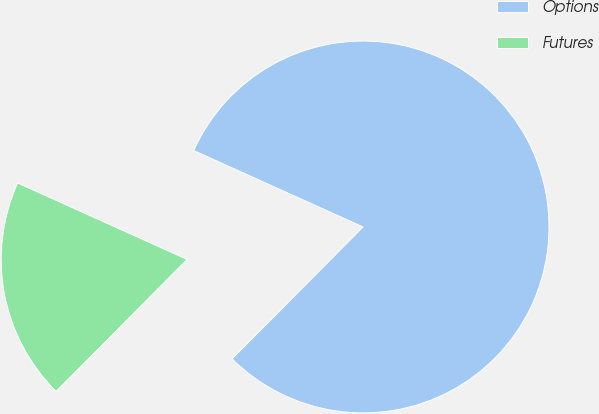<chart> <loc_0><loc_0><loc_500><loc_500><pie_chart><fcel>Options<fcel>Futures<nl><fcel>80.7%<fcel>19.3%<nl></chart> 